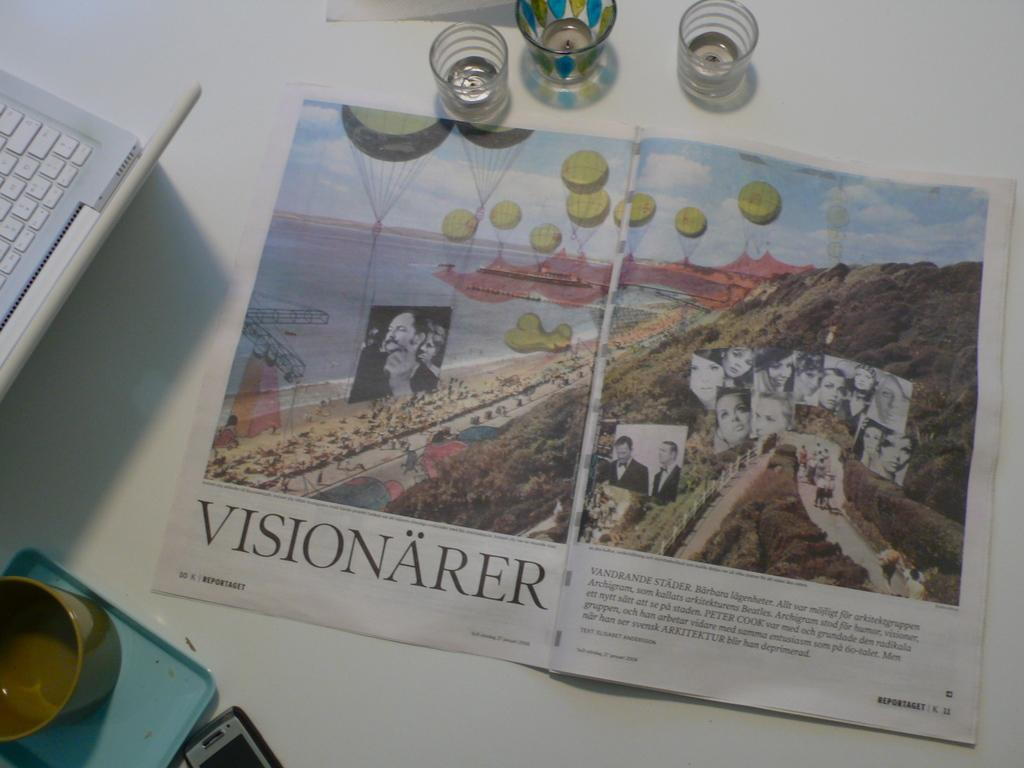Provide a one-sentence caption for the provided image. A magazine sits on a white desk and is open to a page that reads, "Visionärer". 